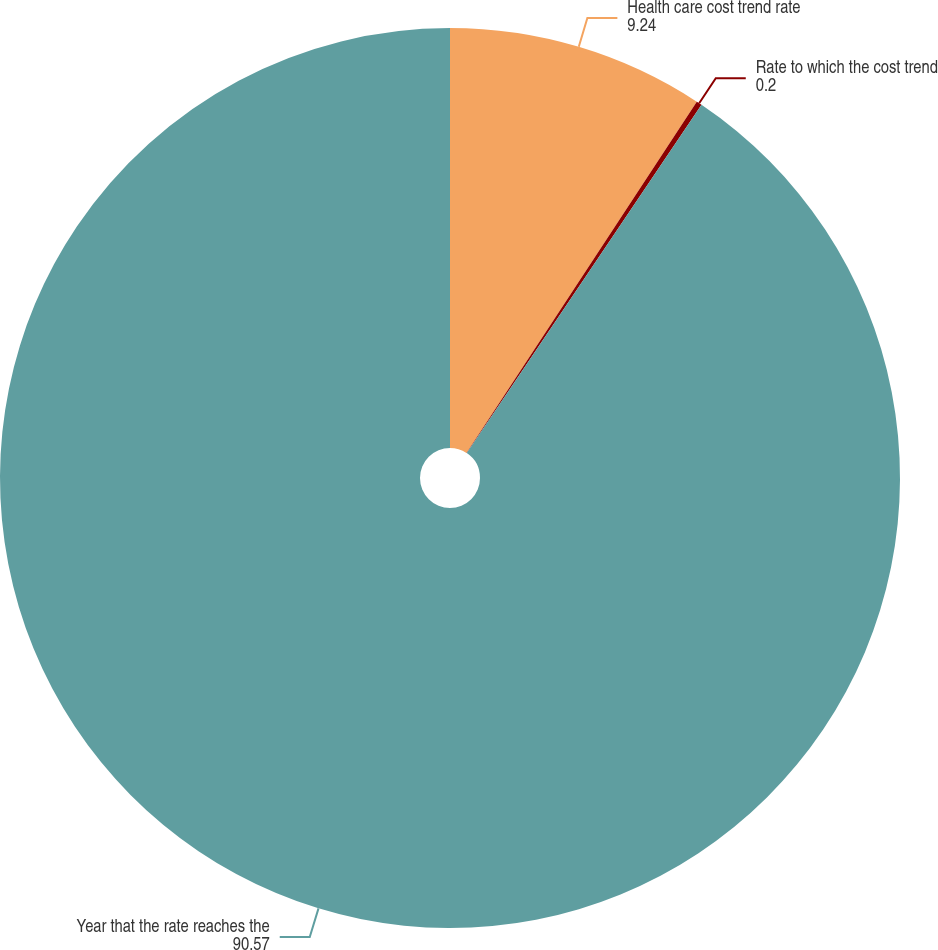Convert chart. <chart><loc_0><loc_0><loc_500><loc_500><pie_chart><fcel>Health care cost trend rate<fcel>Rate to which the cost trend<fcel>Year that the rate reaches the<nl><fcel>9.24%<fcel>0.2%<fcel>90.57%<nl></chart> 